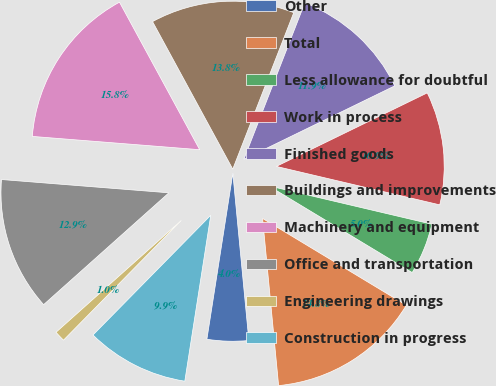<chart> <loc_0><loc_0><loc_500><loc_500><pie_chart><fcel>Other<fcel>Total<fcel>Less allowance for doubtful<fcel>Work in process<fcel>Finished goods<fcel>Buildings and improvements<fcel>Machinery and equipment<fcel>Office and transportation<fcel>Engineering drawings<fcel>Construction in progress<nl><fcel>3.99%<fcel>14.83%<fcel>4.97%<fcel>10.89%<fcel>11.87%<fcel>13.84%<fcel>15.81%<fcel>12.86%<fcel>1.03%<fcel>9.9%<nl></chart> 